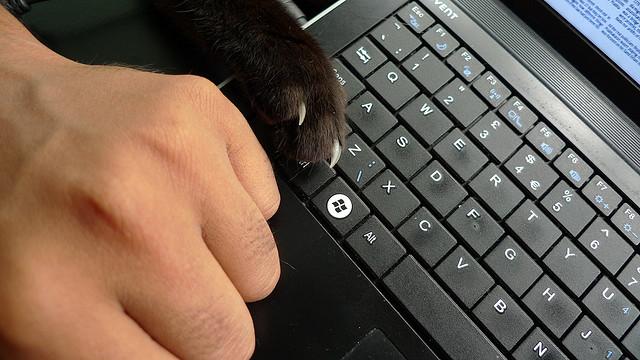What operating system does the computer use?
Short answer required. Windows. Is the animal using the keyboard?
Keep it brief. Yes. What animal can be seen?
Quick response, please. Cat. 